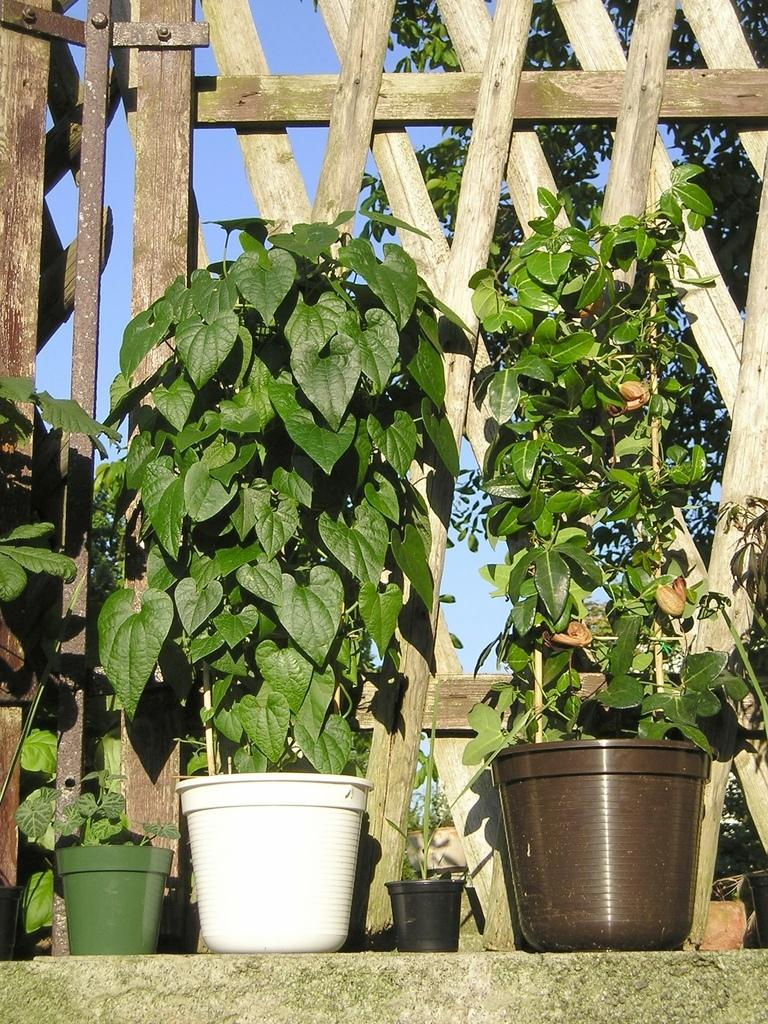What type of objects can be seen in the image? There are plant pots in the image. What material is the fence made of in the image? The fence in the image is made of wood. What can be seen in the background of the image? There are trees and the sky visible in the background of the image. What type of canvas is being used by the giants in the image? There are no giants or canvas present in the image. What is the answer to the question that is not visible in the image? The question that is not visible in the image cannot be answered based on the information provided. 